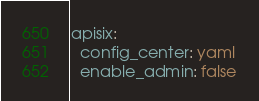<code> <loc_0><loc_0><loc_500><loc_500><_YAML_>apisix:
  config_center: yaml
  enable_admin: false
</code> 